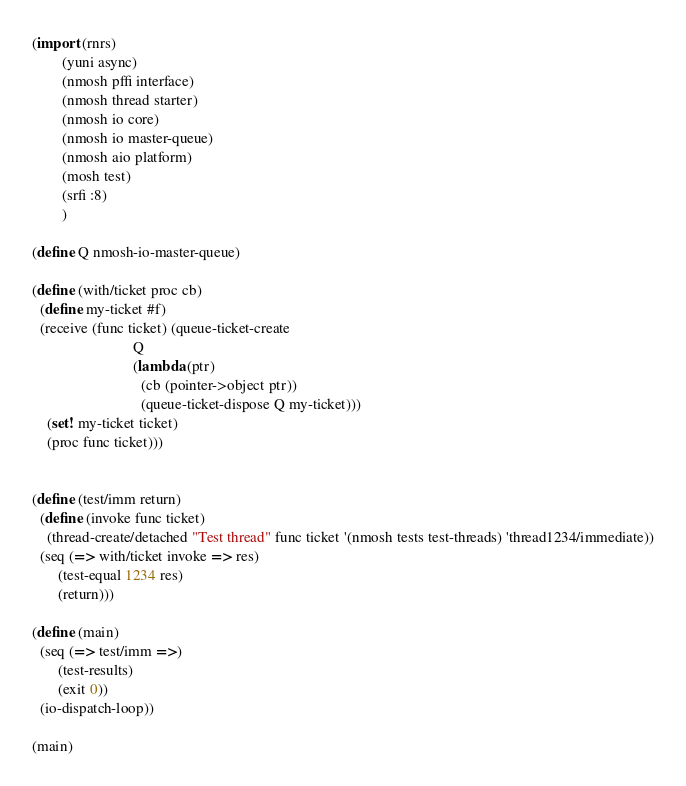Convert code to text. <code><loc_0><loc_0><loc_500><loc_500><_Scheme_>(import (rnrs)
        (yuni async)
        (nmosh pffi interface)
        (nmosh thread starter)
        (nmosh io core)
        (nmosh io master-queue)
        (nmosh aio platform)
        (mosh test)
        (srfi :8)
        )

(define Q nmosh-io-master-queue)

(define (with/ticket proc cb)
  (define my-ticket #f)
  (receive (func ticket) (queue-ticket-create 
                           Q
                           (lambda (ptr)
                             (cb (pointer->object ptr))
                             (queue-ticket-dispose Q my-ticket))) 
    (set! my-ticket ticket)
    (proc func ticket)))


(define (test/imm return)
  (define (invoke func ticket)
    (thread-create/detached "Test thread" func ticket '(nmosh tests test-threads) 'thread1234/immediate))
  (seq (=> with/ticket invoke => res)
       (test-equal 1234 res)
       (return)))

(define (main)
  (seq (=> test/imm =>)
       (test-results)
       (exit 0))
  (io-dispatch-loop))

(main)

</code> 